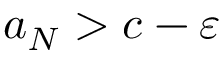Convert formula to latex. <formula><loc_0><loc_0><loc_500><loc_500>a _ { N } > c - \varepsilon</formula> 